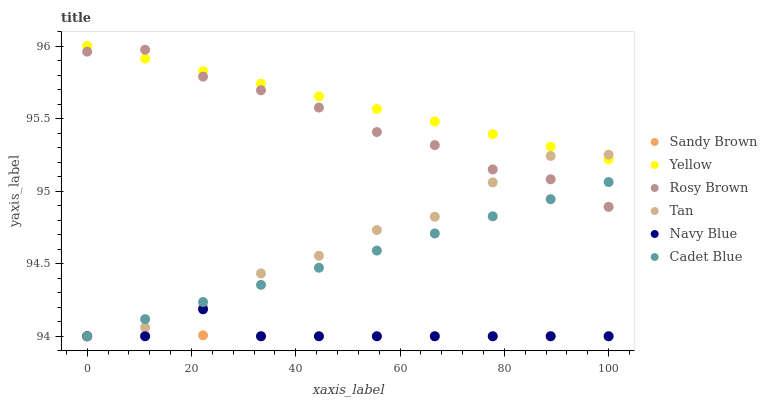Does Sandy Brown have the minimum area under the curve?
Answer yes or no. Yes. Does Yellow have the maximum area under the curve?
Answer yes or no. Yes. Does Navy Blue have the minimum area under the curve?
Answer yes or no. No. Does Navy Blue have the maximum area under the curve?
Answer yes or no. No. Is Yellow the smoothest?
Answer yes or no. Yes. Is Tan the roughest?
Answer yes or no. Yes. Is Navy Blue the smoothest?
Answer yes or no. No. Is Navy Blue the roughest?
Answer yes or no. No. Does Cadet Blue have the lowest value?
Answer yes or no. Yes. Does Rosy Brown have the lowest value?
Answer yes or no. No. Does Yellow have the highest value?
Answer yes or no. Yes. Does Navy Blue have the highest value?
Answer yes or no. No. Is Sandy Brown less than Rosy Brown?
Answer yes or no. Yes. Is Rosy Brown greater than Navy Blue?
Answer yes or no. Yes. Does Cadet Blue intersect Rosy Brown?
Answer yes or no. Yes. Is Cadet Blue less than Rosy Brown?
Answer yes or no. No. Is Cadet Blue greater than Rosy Brown?
Answer yes or no. No. Does Sandy Brown intersect Rosy Brown?
Answer yes or no. No. 